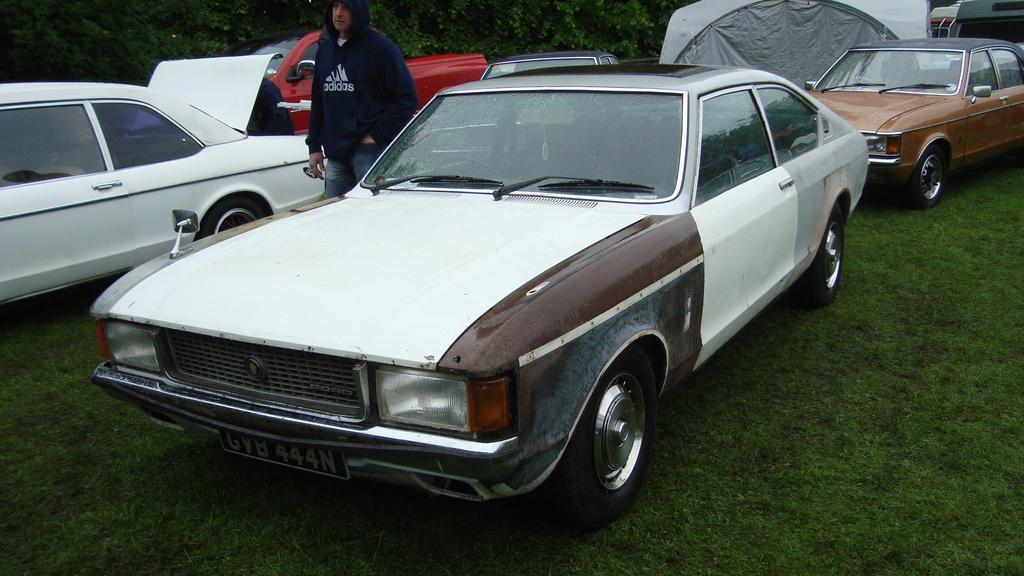In one or two sentences, can you explain what this image depicts? In this image I can see an open grass ground and on it I can see number of vehicles. I can also see one man is standing in the centre and I can see he is wearing a hoodie and jeans. In the background I can see number of trees. 